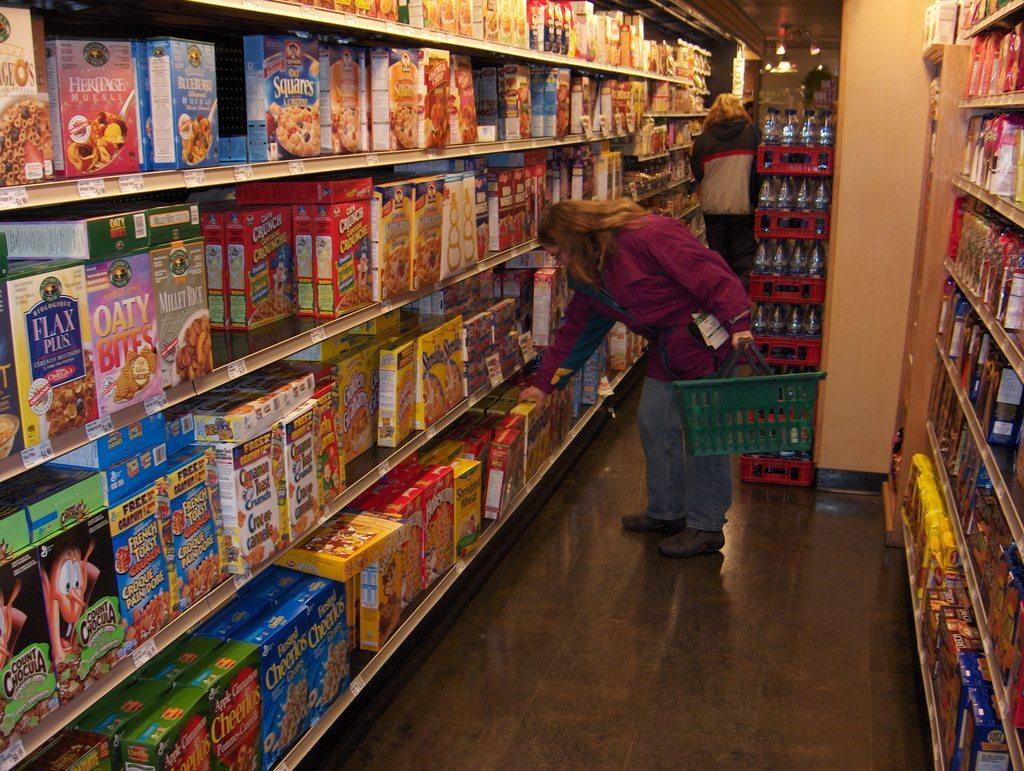<image>
Relay a brief, clear account of the picture shown. Woman shopping for cereal in a store, Cheerios and Cinnamon Toast Crunch. 